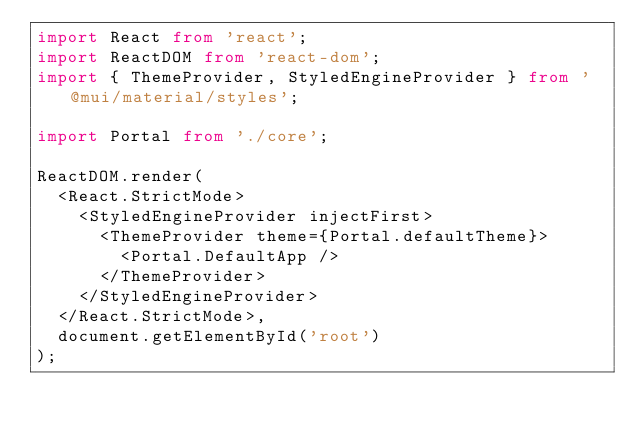Convert code to text. <code><loc_0><loc_0><loc_500><loc_500><_TypeScript_>import React from 'react';
import ReactDOM from 'react-dom';
import { ThemeProvider, StyledEngineProvider } from '@mui/material/styles';

import Portal from './core';

ReactDOM.render(
  <React.StrictMode>
    <StyledEngineProvider injectFirst>
      <ThemeProvider theme={Portal.defaultTheme}>
        <Portal.DefaultApp />
      </ThemeProvider>
    </StyledEngineProvider>
  </React.StrictMode>,
  document.getElementById('root')
);
</code> 